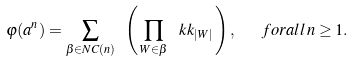<formula> <loc_0><loc_0><loc_500><loc_500>\varphi ( a ^ { n } ) = \sum _ { \beta \in N C ( n ) } \ \left ( \, \prod _ { W \in \beta } \, \ k k _ { | W | } \, \right ) , \ \ \ f o r a l l \, n \geq 1 .</formula> 